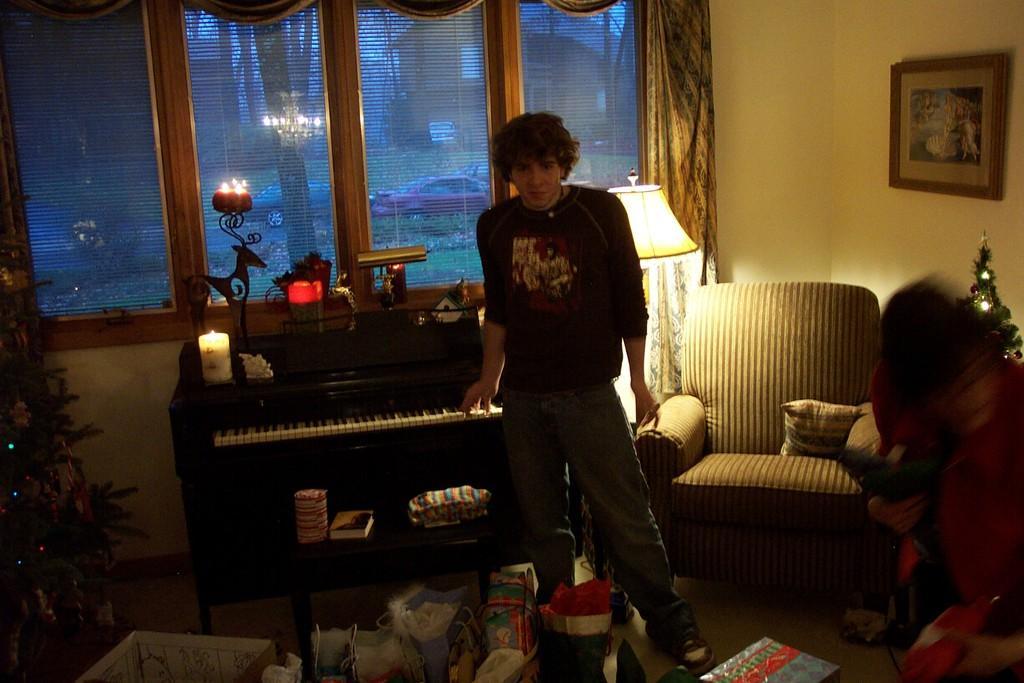Please provide a concise description of this image. In this image we can see one person standing in the middle and placing his hand on the Piano keyboard, we can see one chair behind him, in front we can see some clothes and one box here, on the left side of the image we can see a plant, in the background there is a window and one curtain, on the right side of the image there is a wall and one portrait, there is a pillow on the chair, we can see another person on the right side of the image. 